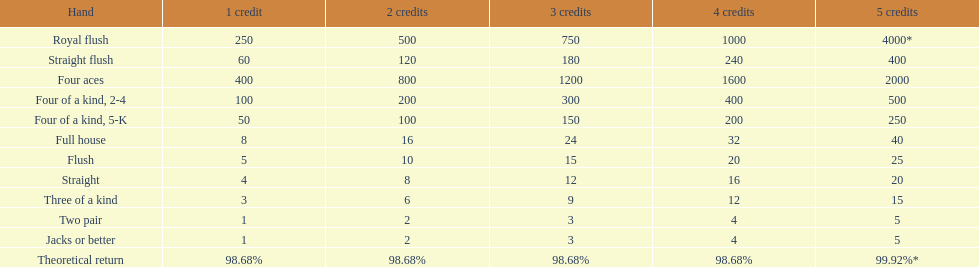What hand ranks below a straight flush? Four aces. What hand ranks below four aces? Four of a kind, 2-4. What hand ranks above between a straight and a flush? Flush. 